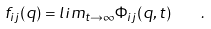<formula> <loc_0><loc_0><loc_500><loc_500>f _ { i j } ( { q } ) = l i m _ { t \to \infty } \Phi _ { i j } ( { q } , t ) \quad .</formula> 